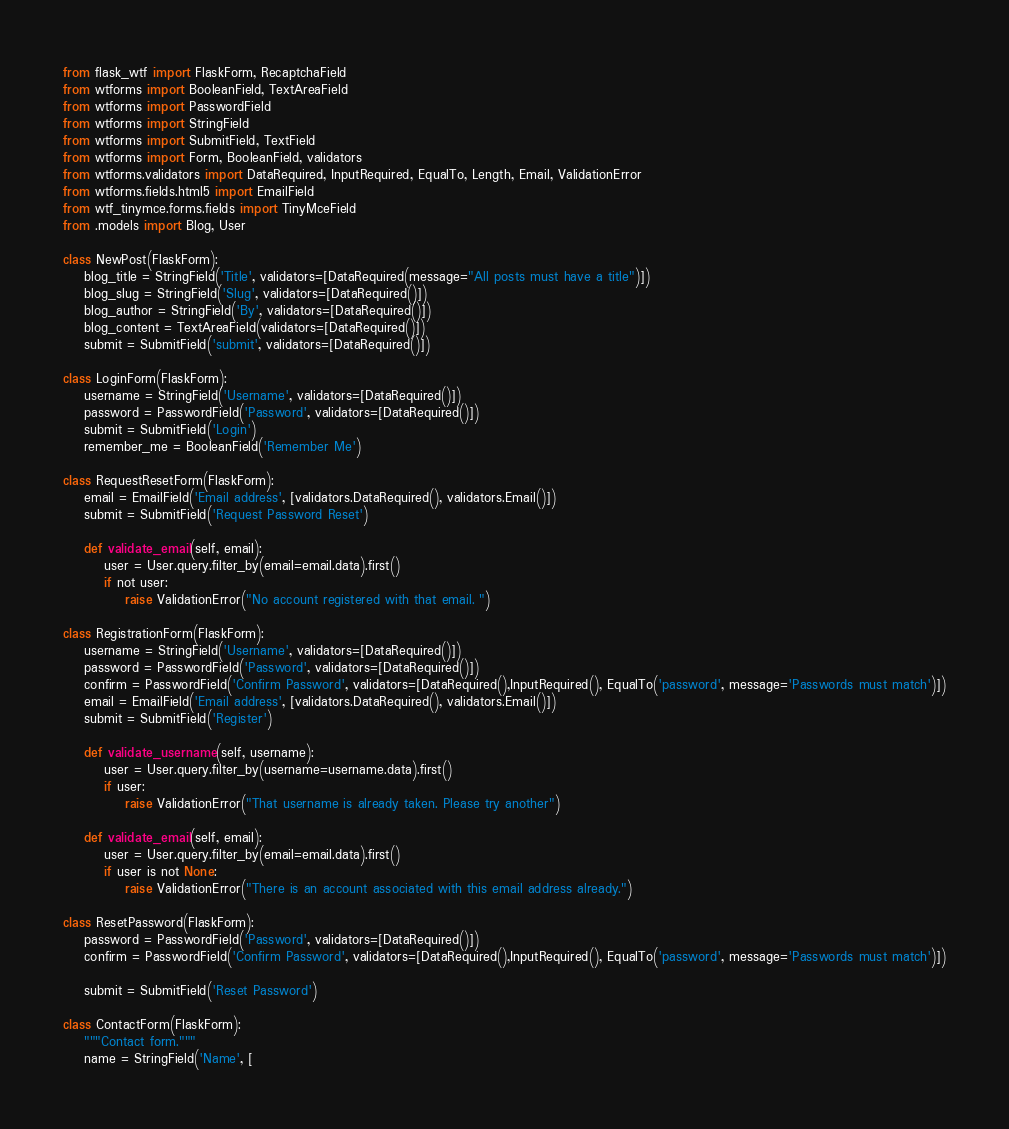<code> <loc_0><loc_0><loc_500><loc_500><_Python_>from flask_wtf import FlaskForm, RecaptchaField
from wtforms import BooleanField, TextAreaField
from wtforms import PasswordField
from wtforms import StringField
from wtforms import SubmitField, TextField
from wtforms import Form, BooleanField, validators
from wtforms.validators import DataRequired, InputRequired, EqualTo, Length, Email, ValidationError
from wtforms.fields.html5 import EmailField
from wtf_tinymce.forms.fields import TinyMceField
from .models import Blog, User

class NewPost(FlaskForm):
    blog_title = StringField('Title', validators=[DataRequired(message="All posts must have a title")])
    blog_slug = StringField('Slug', validators=[DataRequired()])
    blog_author = StringField('By', validators=[DataRequired()])
    blog_content = TextAreaField(validators=[DataRequired()])
    submit = SubmitField('submit', validators=[DataRequired()])

class LoginForm(FlaskForm):
    username = StringField('Username', validators=[DataRequired()])
    password = PasswordField('Password', validators=[DataRequired()])
    submit = SubmitField('Login')
    remember_me = BooleanField('Remember Me')

class RequestResetForm(FlaskForm):
    email = EmailField('Email address', [validators.DataRequired(), validators.Email()])
    submit = SubmitField('Request Password Reset')

    def validate_email(self, email):
        user = User.query.filter_by(email=email.data).first()
        if not user:
            raise ValidationError("No account registered with that email. ")

class RegistrationForm(FlaskForm):
    username = StringField('Username', validators=[DataRequired()])
    password = PasswordField('Password', validators=[DataRequired()])
    confirm = PasswordField('Confirm Password', validators=[DataRequired(),InputRequired(), EqualTo('password', message='Passwords must match')])
    email = EmailField('Email address', [validators.DataRequired(), validators.Email()])
    submit = SubmitField('Register')

    def validate_username(self, username):
        user = User.query.filter_by(username=username.data).first()
        if user:
            raise ValidationError("That username is already taken. Please try another")

    def validate_email(self, email):
        user = User.query.filter_by(email=email.data).first()
        if user is not None:
            raise ValidationError("There is an account associated with this email address already.")

class ResetPassword(FlaskForm):
    password = PasswordField('Password', validators=[DataRequired()])
    confirm = PasswordField('Confirm Password', validators=[DataRequired(),InputRequired(), EqualTo('password', message='Passwords must match')])

    submit = SubmitField('Reset Password')

class ContactForm(FlaskForm):
    """Contact form."""
    name = StringField('Name', [</code> 